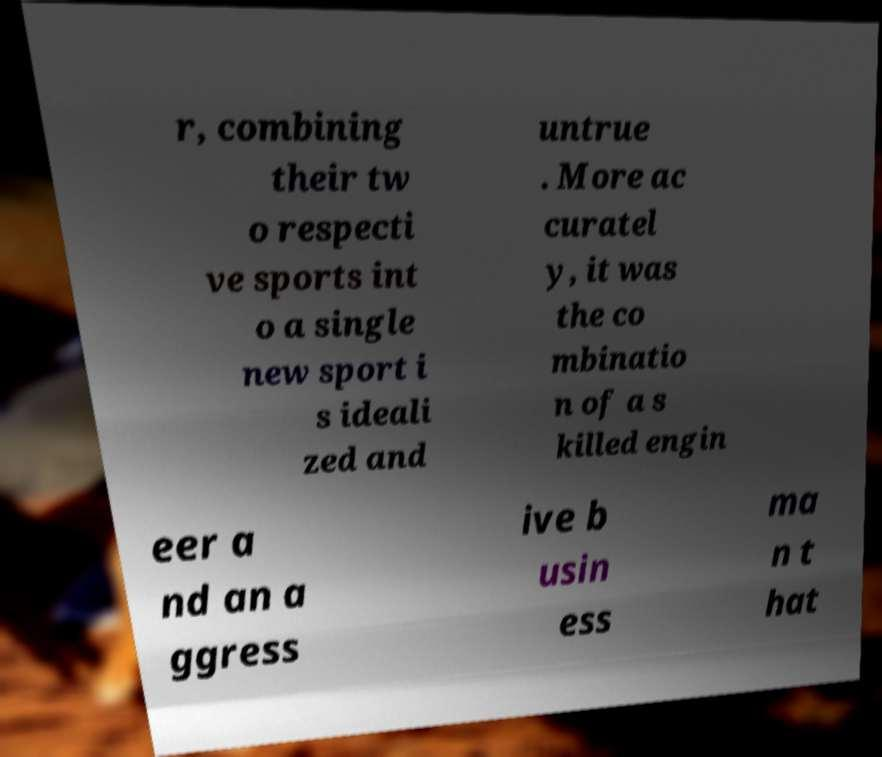For documentation purposes, I need the text within this image transcribed. Could you provide that? r, combining their tw o respecti ve sports int o a single new sport i s ideali zed and untrue . More ac curatel y, it was the co mbinatio n of a s killed engin eer a nd an a ggress ive b usin ess ma n t hat 